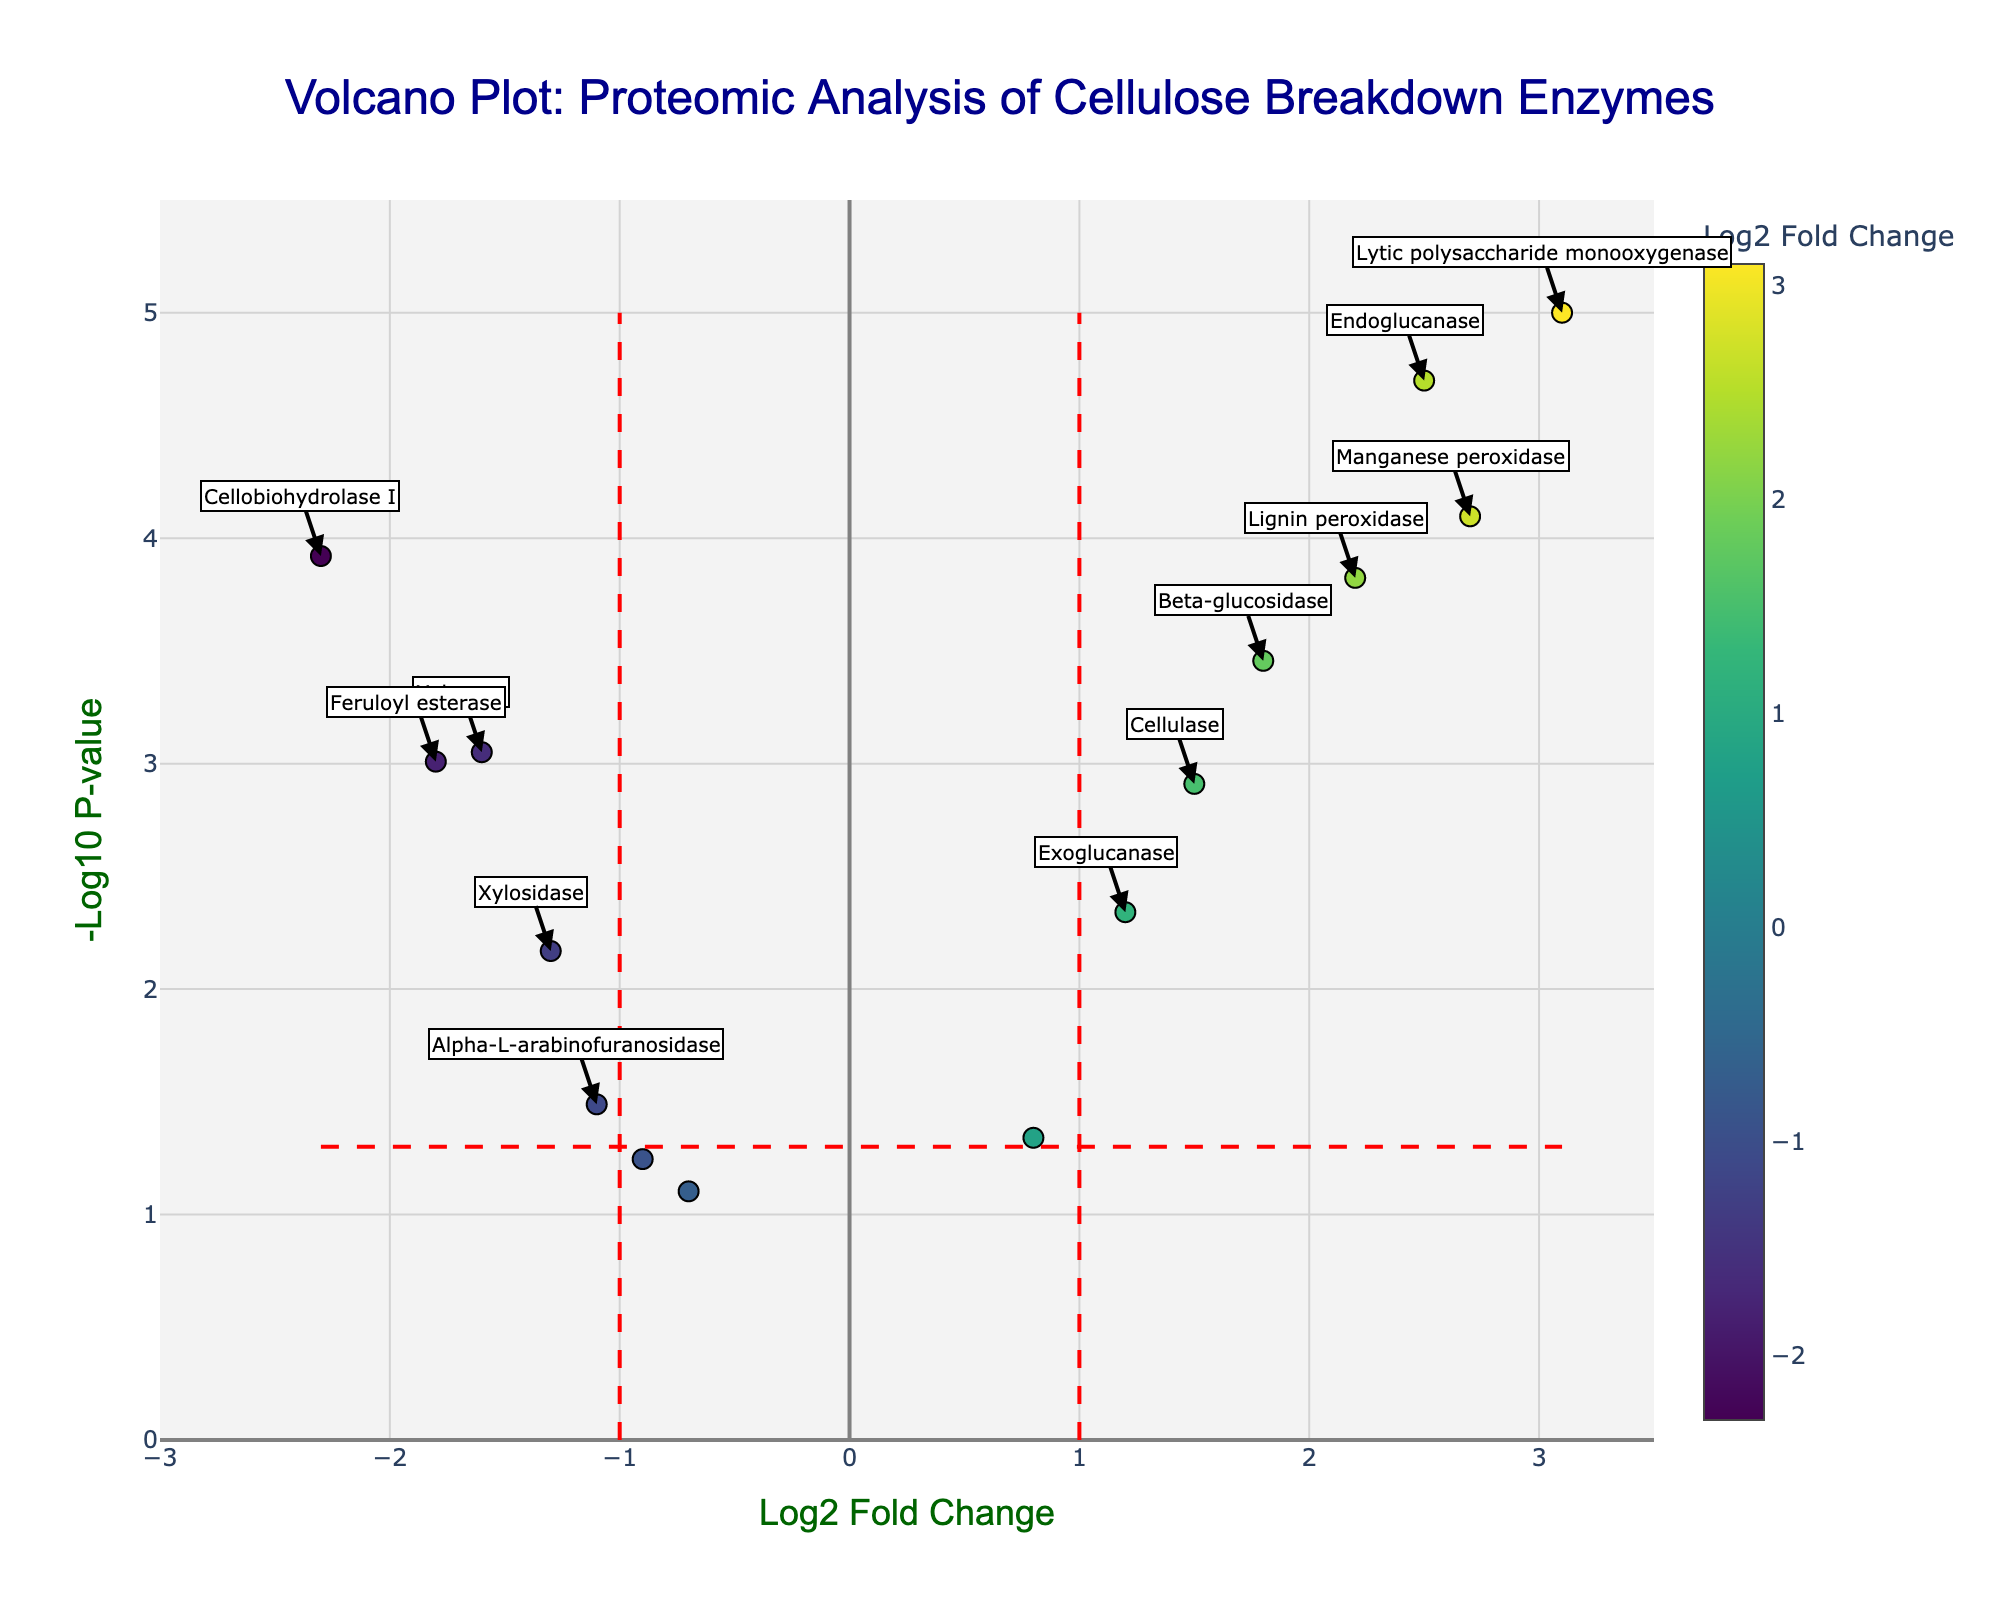What is the title of the Volcano Plot? The title is generally located at the top of the plot and provides a brief summary of the data being visualized. In this case, the title reads "Volcano Plot: Proteomic Analysis of Cellulose Breakdown Enzymes," indicating that the plot shows data from a proteomic analysis focused on enzymes involved in cellulose breakdown.
Answer: Volcano Plot: Proteomic Analysis of Cellulose Breakdown Enzymes What are the axes labeled? The axes labels usually explain what each axis represents. The x-axis is labeled "Log2 Fold Change," indicating it shows the log2 fold changes of protein expression levels. The y-axis is labeled "-Log10 P-value," meaning it displays the -log10 of the p-values, which measures the statistical significance.
Answer: Log2 Fold Change and -Log10 P-value Which protein has the highest -log10 p-value and what does this signify? The protein with the highest -log10 p-value is the one plotted at the highest point on the y-axis. According to the data provided, "Lytic polysaccharide monooxygenase" has the highest -log10 p-value of -log10(0.00001) which equals 5. This indicates it is the most statistically significant protein in the study.
Answer: Lytic polysaccharide monooxygenase; it signifies the highest statistical significance How many proteins have a log2 fold change greater than 1 and a p-value less than 0.05? To find the number of proteins with log2 fold changes greater than 1 and p-values less than 0.05, look for points that are right of the vertical significance line at log2 fold change = 1 and above the horizontal significance line at -log10(p-value) = 1.3. From the data, these proteins are Beta-glucosidase, Endoglucanase, Lytic polysaccharide monooxygenase, Exoglucanase, Manganese peroxidase, Cellulase, and Lignin peroxidase.
Answer: 7 proteins Which proteins are considered down-regulated with significant p-values? Down-regulated proteins will have a negative log2 fold change. Significance is typically indicated by being above the horizontal line representing p = 0.05 (-log10(p-value)=1.3). Referring to the data and visual plot, "Cellobiohydrolase I," "Xylanase," and "Feruloyl esterase" meet the criteria.
Answer: Cellobiohydrolase I, Xylanase, and Feruloyl esterase Compare the log2 fold changes for "Xylanase" and "Cellulose Dehydrogenase". Which has a greater absolute fold change and by how much? The log2 fold change for "Xylanase" is -1.6 and for "Cellulose Dehydrogenase" it is -0.9. The absolute fold change is the absolute value of these log2 fold changes. Therefore, the absolute fold change for "Xylanase" is 1.6, and for "Cellulose Dehydrogenase" it is 0.9. 1.6 - 0.9 = 0.7, so Xylanase has a greater absolute fold change by 0.7.
Answer: Xylanase by 0.7 What is the exact p-value for "Manganese peroxidase" and why is it important? The exact p-value can be obtained from the hover text or annotation. For "Manganese peroxidase," the p-value is given as 0.00008. A smaller p-value indicates stronger evidence against the null hypothesis, suggesting that the protein's change in expression is statistically significant and unlikely to be due to random chance.
Answer: 0.00008; indicates high statistical significance Based on the plot, list all enzymes that are significantly  up-regulated. Up-regulated proteins have positive log2 fold changes. Significance is denoted by being above the p=0.05 threshold. Referring to the visual, these enzymes are "Beta-glucosidase," "Endoglucanase," "Lytic polysaccharide monooxygenase," "Exoglucanase," "Manganese peroxidase," "Cellulase," and "Lignin peroxidase."
Answer: Beta-glucosidase, Endoglucanase, Lytic polysaccharide monooxygenase, Exoglucanase, Manganese peroxidase, Cellulase, and Lignin peroxidase 